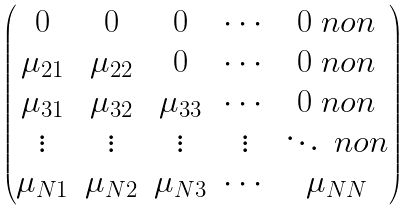Convert formula to latex. <formula><loc_0><loc_0><loc_500><loc_500>\begin{pmatrix} 0 & 0 & 0 & \cdots & 0 \ n o n \\ \mu _ { 2 1 } & \mu _ { 2 2 } & 0 & \cdots & 0 \ n o n \\ \mu _ { 3 1 } & \mu _ { 3 2 } & \mu _ { 3 3 } & \cdots & 0 \ n o n \\ \vdots & \vdots & \vdots & \vdots & \ddots \ n o n \\ \mu _ { N 1 } & \mu _ { N 2 } & \mu _ { N 3 } & \cdots & \mu _ { N N } \end{pmatrix}</formula> 